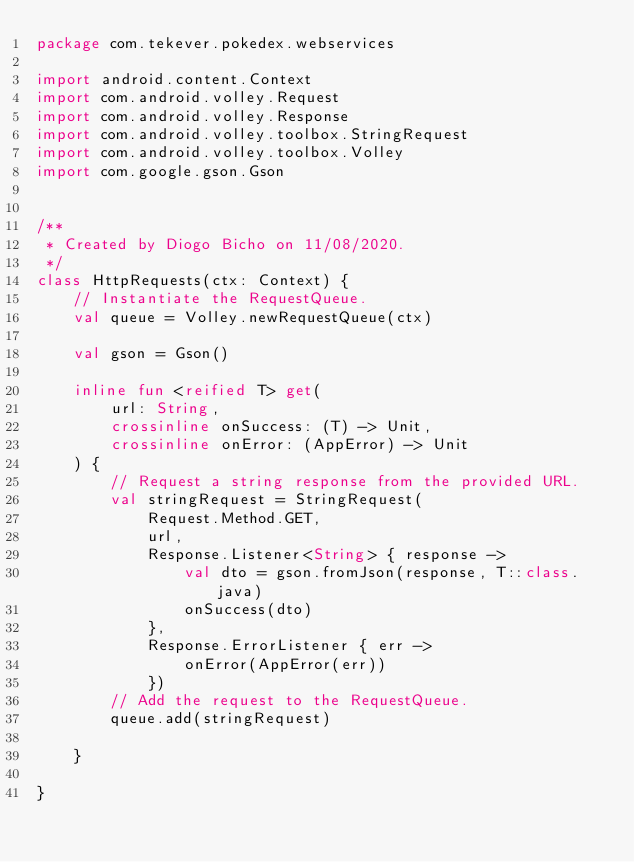<code> <loc_0><loc_0><loc_500><loc_500><_Kotlin_>package com.tekever.pokedex.webservices

import android.content.Context
import com.android.volley.Request
import com.android.volley.Response
import com.android.volley.toolbox.StringRequest
import com.android.volley.toolbox.Volley
import com.google.gson.Gson


/**
 * Created by Diogo Bicho on 11/08/2020.
 */
class HttpRequests(ctx: Context) {
    // Instantiate the RequestQueue.
    val queue = Volley.newRequestQueue(ctx)

    val gson = Gson()

    inline fun <reified T> get(
        url: String,
        crossinline onSuccess: (T) -> Unit,
        crossinline onError: (AppError) -> Unit
    ) {
        // Request a string response from the provided URL.
        val stringRequest = StringRequest(
            Request.Method.GET,
            url,
            Response.Listener<String> { response ->
                val dto = gson.fromJson(response, T::class.java)
                onSuccess(dto)
            },
            Response.ErrorListener { err ->
                onError(AppError(err))
            })
        // Add the request to the RequestQueue.
        queue.add(stringRequest)

    }

}</code> 